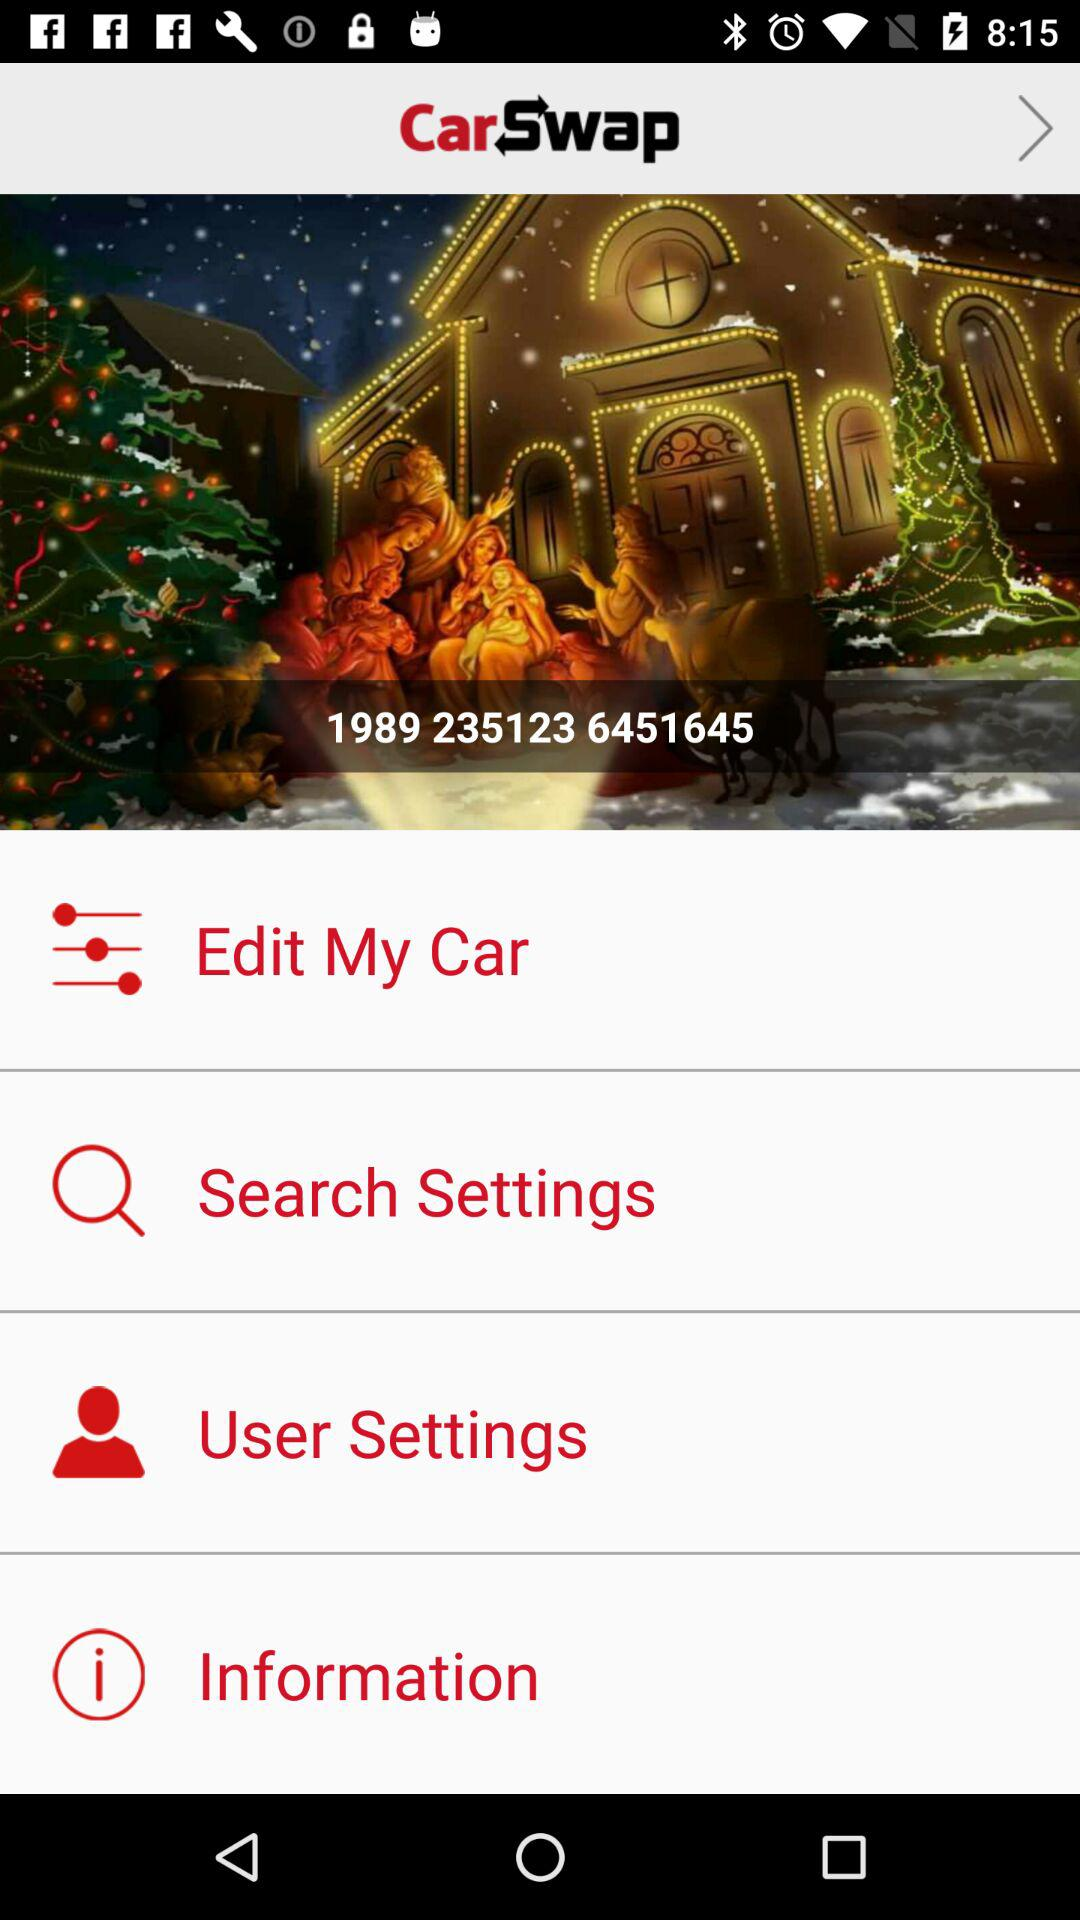Where is the car located?
When the provided information is insufficient, respond with <no answer>. <no answer> 